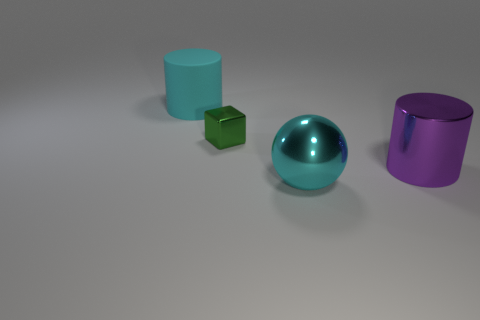Add 1 purple cylinders. How many objects exist? 5 Subtract 0 gray cubes. How many objects are left? 4 Subtract all cubes. How many objects are left? 3 Subtract all small objects. Subtract all small metal balls. How many objects are left? 3 Add 2 green blocks. How many green blocks are left? 3 Add 3 yellow metallic blocks. How many yellow metallic blocks exist? 3 